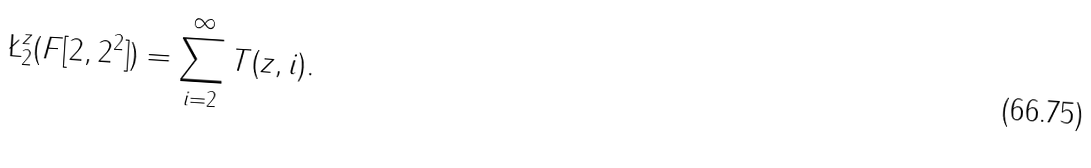<formula> <loc_0><loc_0><loc_500><loc_500>\L _ { 2 } ^ { z } ( F [ 2 , 2 ^ { 2 } ] ) = \sum _ { i = 2 } ^ { \infty } T ( z , i ) .</formula> 